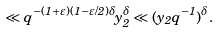<formula> <loc_0><loc_0><loc_500><loc_500>\ll q ^ { - ( 1 + \varepsilon ) ( 1 - \varepsilon / 2 ) \delta } y _ { 2 } ^ { \delta } \ll ( y _ { 2 } q ^ { - 1 } ) ^ { \delta } .</formula> 